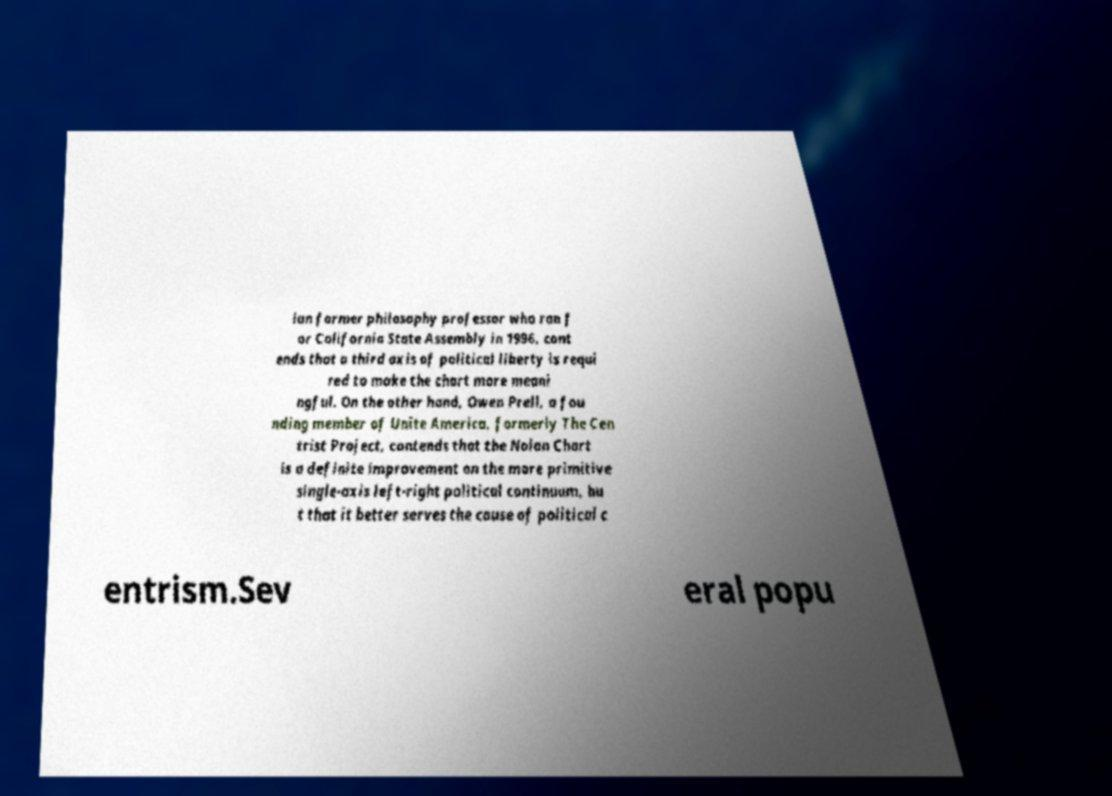Can you accurately transcribe the text from the provided image for me? ian former philosophy professor who ran f or California State Assembly in 1996, cont ends that a third axis of political liberty is requi red to make the chart more meani ngful. On the other hand, Owen Prell, a fou nding member of Unite America, formerly The Cen trist Project, contends that the Nolan Chart is a definite improvement on the more primitive single-axis left-right political continuum, bu t that it better serves the cause of political c entrism.Sev eral popu 